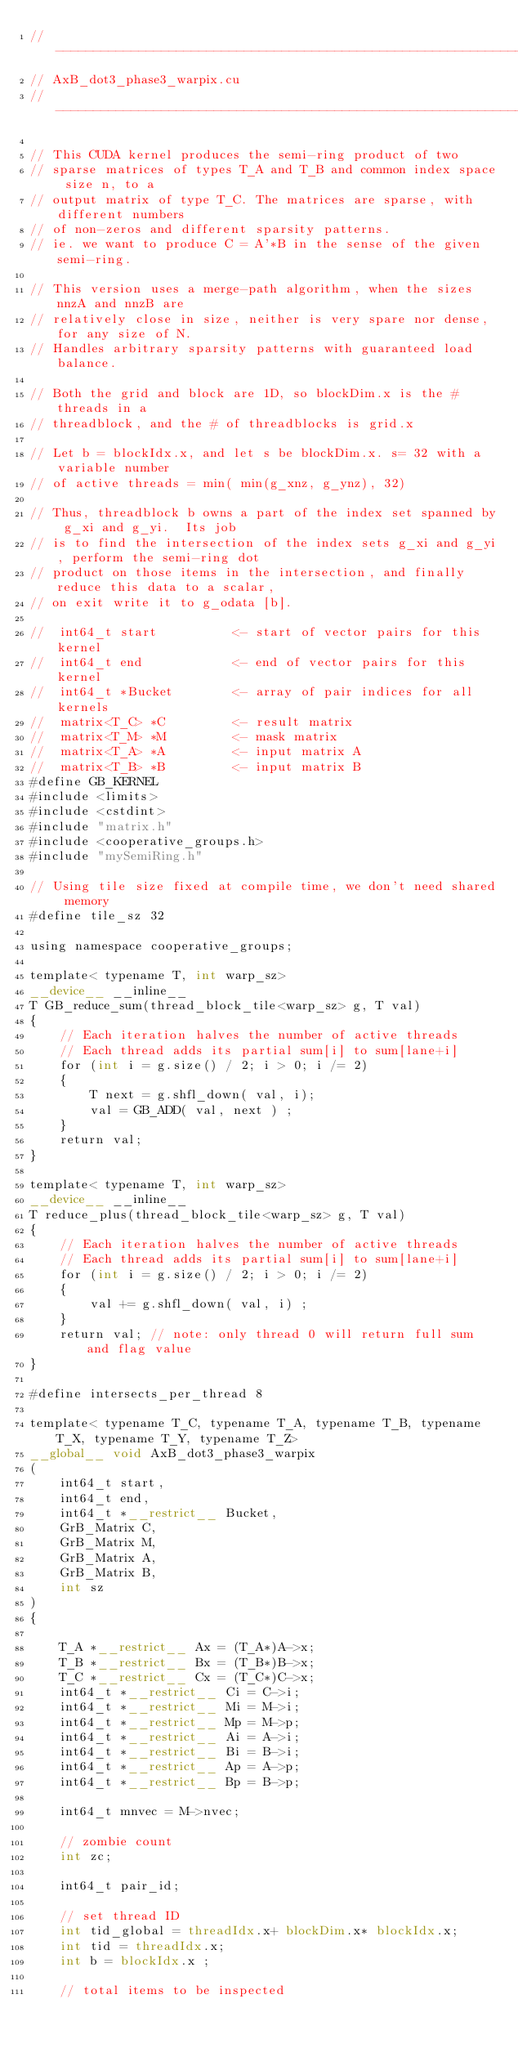<code> <loc_0><loc_0><loc_500><loc_500><_Cuda_>//------------------------------------------------------------------------------
// AxB_dot3_phase3_warpix.cu 
//------------------------------------------------------------------------------

// This CUDA kernel produces the semi-ring product of two
// sparse matrices of types T_A and T_B and common index space size n, to a  
// output matrix of type T_C. The matrices are sparse, with different numbers
// of non-zeros and different sparsity patterns. 
// ie. we want to produce C = A'*B in the sense of the given semi-ring.

// This version uses a merge-path algorithm, when the sizes nnzA and nnzB are 
// relatively close in size, neither is very spare nor dense, for any size of N.
// Handles arbitrary sparsity patterns with guaranteed load balance.

// Both the grid and block are 1D, so blockDim.x is the # threads in a
// threadblock, and the # of threadblocks is grid.x

// Let b = blockIdx.x, and let s be blockDim.x. s= 32 with a variable number
// of active threads = min( min(g_xnz, g_ynz), 32) 

// Thus, threadblock b owns a part of the index set spanned by g_xi and g_yi.  Its job
// is to find the intersection of the index sets g_xi and g_yi, perform the semi-ring dot
// product on those items in the intersection, and finally reduce this data to a scalar, 
// on exit write it to g_odata [b].

//  int64_t start          <- start of vector pairs for this kernel
//  int64_t end            <- end of vector pairs for this kernel
//  int64_t *Bucket        <- array of pair indices for all kernels 
//  matrix<T_C> *C         <- result matrix 
//  matrix<T_M> *M         <- mask matrix
//  matrix<T_A> *A         <- input matrix A
//  matrix<T_B> *B         <- input matrix B
#define GB_KERNEL
#include <limits>
#include <cstdint>
#include "matrix.h"
#include <cooperative_groups.h>
#include "mySemiRing.h"

// Using tile size fixed at compile time, we don't need shared memory
#define tile_sz 32 

using namespace cooperative_groups;

template< typename T, int warp_sz>
__device__ __inline__ 
T GB_reduce_sum(thread_block_tile<warp_sz> g, T val)
{
    // Each iteration halves the number of active threads
    // Each thread adds its partial sum[i] to sum[lane+i]
    for (int i = g.size() / 2; i > 0; i /= 2)
    {
        T next = g.shfl_down( val, i);
        val = GB_ADD( val, next ) ;
    }
    return val;
}

template< typename T, int warp_sz>
__device__ __inline__ 
T reduce_plus(thread_block_tile<warp_sz> g, T val)
{
    // Each iteration halves the number of active threads
    // Each thread adds its partial sum[i] to sum[lane+i]
    for (int i = g.size() / 2; i > 0; i /= 2)
    {
        val += g.shfl_down( val, i) ;
    }
    return val; // note: only thread 0 will return full sum and flag value
}

#define intersects_per_thread 8

template< typename T_C, typename T_A, typename T_B, typename T_X, typename T_Y, typename T_Z>  
__global__ void AxB_dot3_phase3_warpix
(
    int64_t start,
    int64_t end,
    int64_t *__restrict__ Bucket,
    GrB_Matrix C,
    GrB_Matrix M,
    GrB_Matrix A,
    GrB_Matrix B,
    int sz
)
{

    T_A *__restrict__ Ax = (T_A*)A->x;
    T_B *__restrict__ Bx = (T_B*)B->x;
    T_C *__restrict__ Cx = (T_C*)C->x;
    int64_t *__restrict__ Ci = C->i;
    int64_t *__restrict__ Mi = M->i;
    int64_t *__restrict__ Mp = M->p;
    int64_t *__restrict__ Ai = A->i;
    int64_t *__restrict__ Bi = B->i;
    int64_t *__restrict__ Ap = A->p;
    int64_t *__restrict__ Bp = B->p;

    int64_t mnvec = M->nvec;

    // zombie count
    int zc;

    int64_t pair_id;

    // set thread ID
    int tid_global = threadIdx.x+ blockDim.x* blockIdx.x;
    int tid = threadIdx.x;
    int b = blockIdx.x ;

    // total items to be inspected</code> 